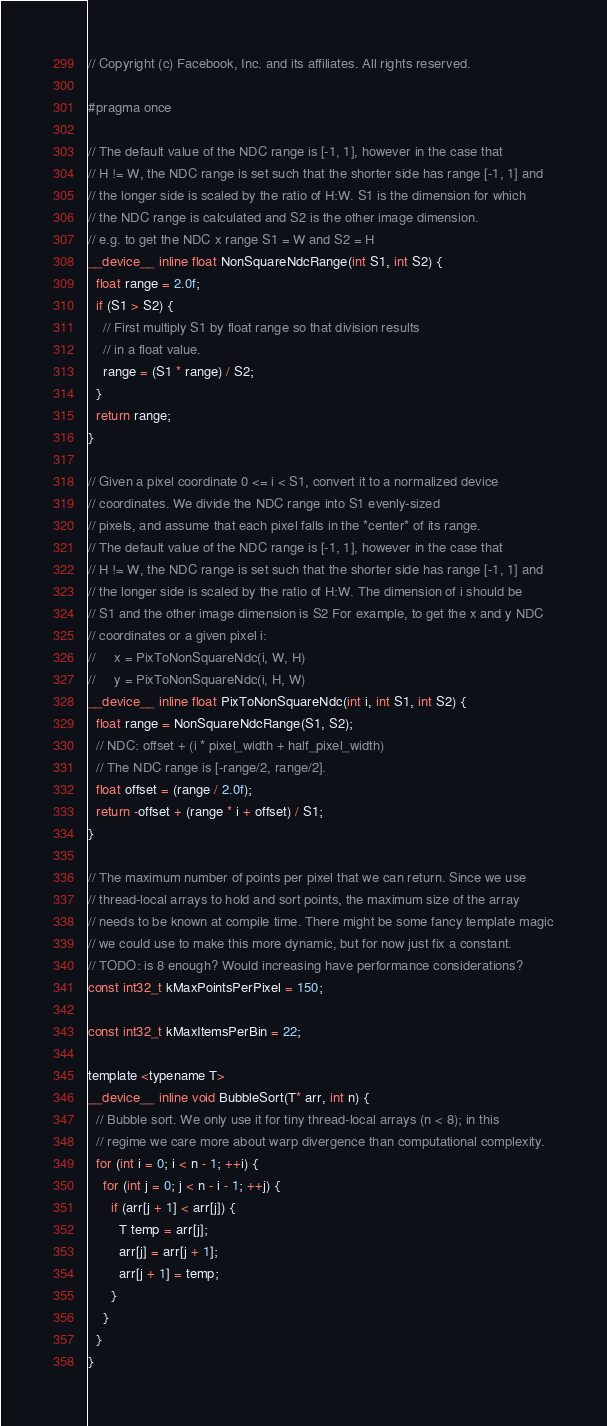<code> <loc_0><loc_0><loc_500><loc_500><_Cuda_>// Copyright (c) Facebook, Inc. and its affiliates. All rights reserved.

#pragma once

// The default value of the NDC range is [-1, 1], however in the case that
// H != W, the NDC range is set such that the shorter side has range [-1, 1] and
// the longer side is scaled by the ratio of H:W. S1 is the dimension for which
// the NDC range is calculated and S2 is the other image dimension.
// e.g. to get the NDC x range S1 = W and S2 = H
__device__ inline float NonSquareNdcRange(int S1, int S2) {
  float range = 2.0f;
  if (S1 > S2) {
    // First multiply S1 by float range so that division results
    // in a float value.
    range = (S1 * range) / S2;
  }
  return range;
}

// Given a pixel coordinate 0 <= i < S1, convert it to a normalized device
// coordinates. We divide the NDC range into S1 evenly-sized
// pixels, and assume that each pixel falls in the *center* of its range.
// The default value of the NDC range is [-1, 1], however in the case that
// H != W, the NDC range is set such that the shorter side has range [-1, 1] and
// the longer side is scaled by the ratio of H:W. The dimension of i should be
// S1 and the other image dimension is S2 For example, to get the x and y NDC
// coordinates or a given pixel i:
//     x = PixToNonSquareNdc(i, W, H)
//     y = PixToNonSquareNdc(i, H, W)
__device__ inline float PixToNonSquareNdc(int i, int S1, int S2) {
  float range = NonSquareNdcRange(S1, S2);
  // NDC: offset + (i * pixel_width + half_pixel_width)
  // The NDC range is [-range/2, range/2].
  float offset = (range / 2.0f);
  return -offset + (range * i + offset) / S1;
}

// The maximum number of points per pixel that we can return. Since we use
// thread-local arrays to hold and sort points, the maximum size of the array
// needs to be known at compile time. There might be some fancy template magic
// we could use to make this more dynamic, but for now just fix a constant.
// TODO: is 8 enough? Would increasing have performance considerations?
const int32_t kMaxPointsPerPixel = 150;

const int32_t kMaxItemsPerBin = 22;

template <typename T>
__device__ inline void BubbleSort(T* arr, int n) {
  // Bubble sort. We only use it for tiny thread-local arrays (n < 8); in this
  // regime we care more about warp divergence than computational complexity.
  for (int i = 0; i < n - 1; ++i) {
    for (int j = 0; j < n - i - 1; ++j) {
      if (arr[j + 1] < arr[j]) {
        T temp = arr[j];
        arr[j] = arr[j + 1];
        arr[j + 1] = temp;
      }
    }
  }
}
</code> 